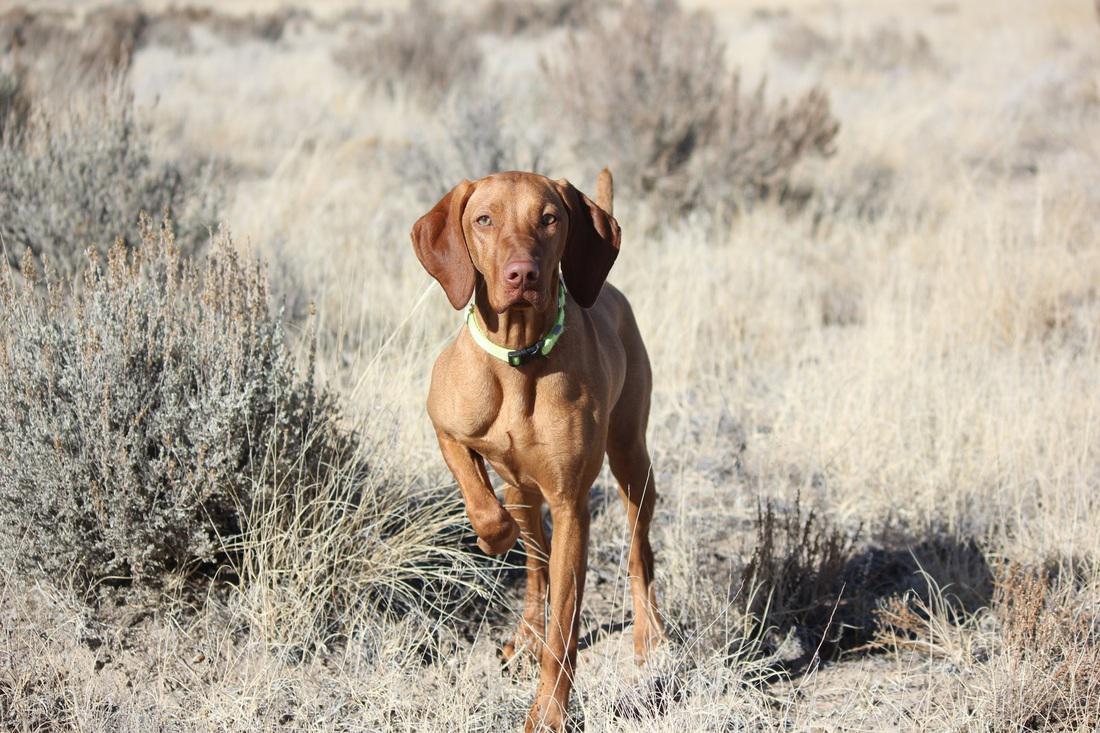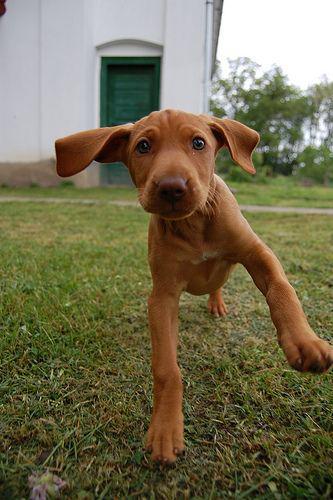The first image is the image on the left, the second image is the image on the right. Given the left and right images, does the statement "At least one image shows one red-orange dog standing with head and body in profile turned leftward, and tail extended." hold true? Answer yes or no. No. The first image is the image on the left, the second image is the image on the right. Given the left and right images, does the statement "A brown dog stand straight looking to the left while on the grass." hold true? Answer yes or no. No. 